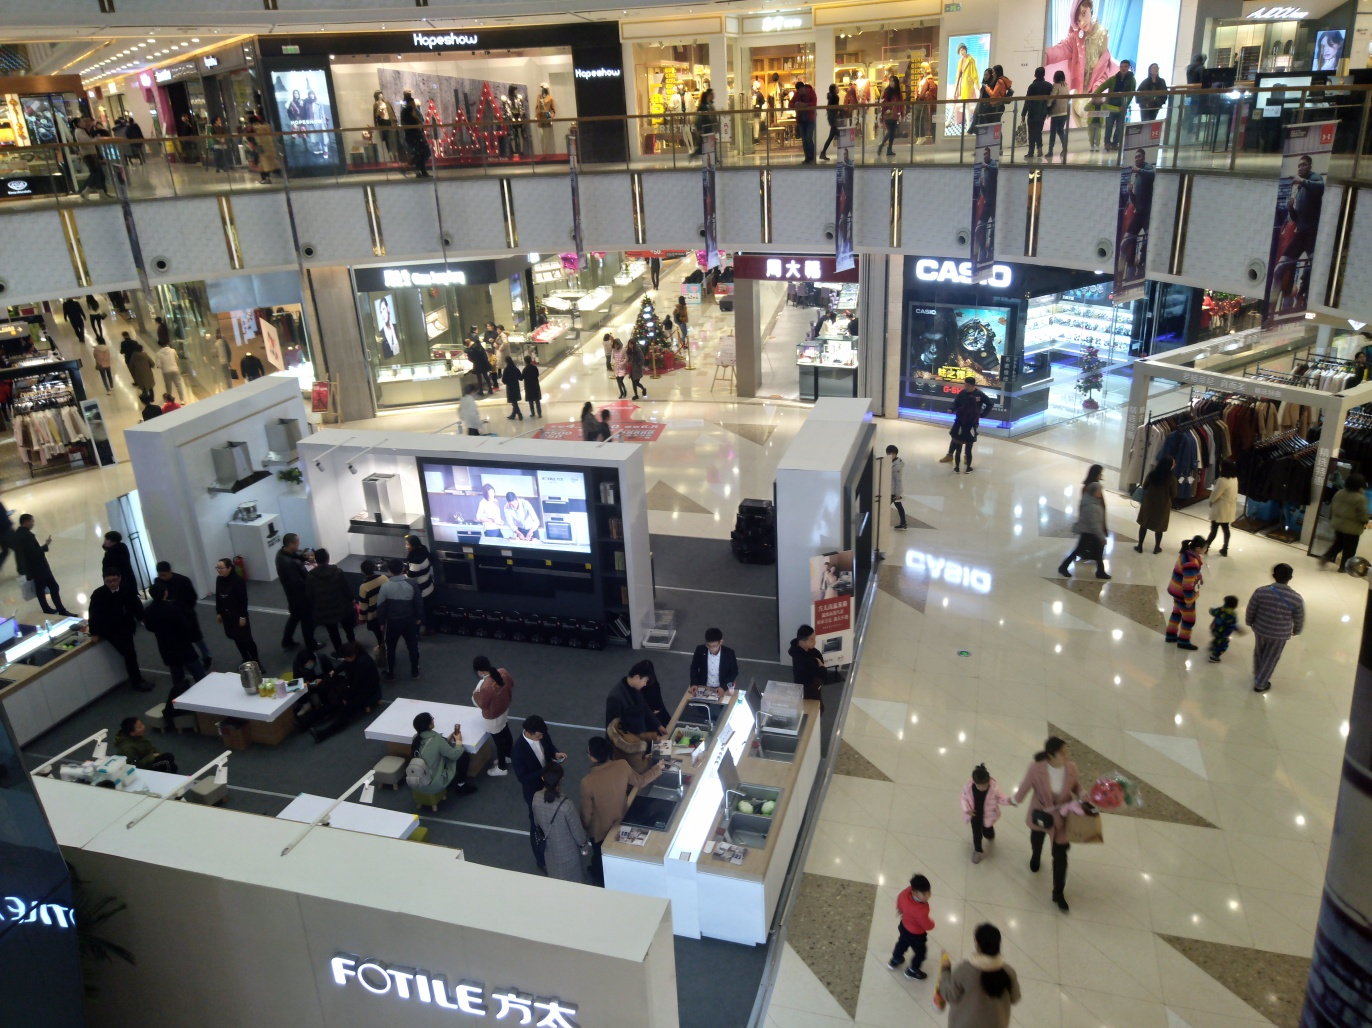Is the lighting bright in the photo?
 Yes 